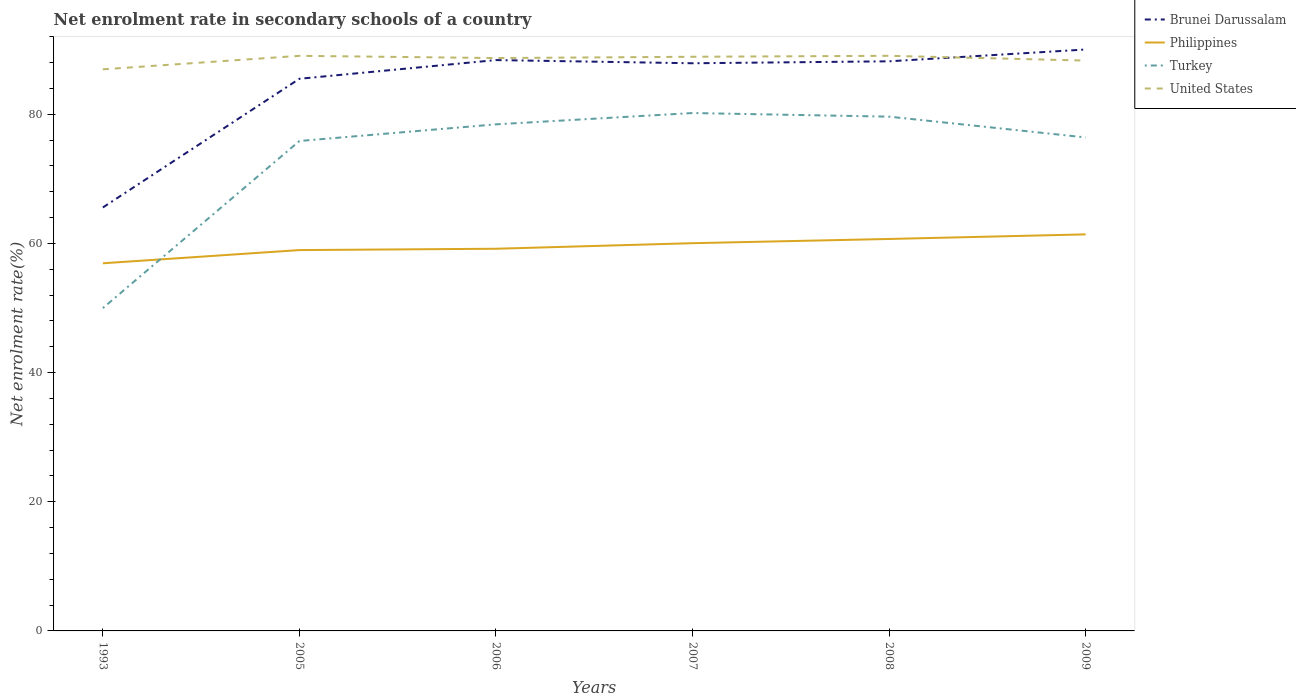How many different coloured lines are there?
Offer a very short reply. 4. Does the line corresponding to Philippines intersect with the line corresponding to Turkey?
Your answer should be compact. Yes. Across all years, what is the maximum net enrolment rate in secondary schools in United States?
Your answer should be compact. 86.95. What is the total net enrolment rate in secondary schools in Brunei Darussalam in the graph?
Give a very brief answer. -22.33. What is the difference between the highest and the second highest net enrolment rate in secondary schools in Brunei Darussalam?
Ensure brevity in your answer.  24.46. Is the net enrolment rate in secondary schools in Brunei Darussalam strictly greater than the net enrolment rate in secondary schools in Philippines over the years?
Your answer should be very brief. No. What is the difference between two consecutive major ticks on the Y-axis?
Give a very brief answer. 20. Does the graph contain grids?
Your response must be concise. No. Where does the legend appear in the graph?
Ensure brevity in your answer.  Top right. How many legend labels are there?
Ensure brevity in your answer.  4. How are the legend labels stacked?
Make the answer very short. Vertical. What is the title of the graph?
Provide a short and direct response. Net enrolment rate in secondary schools of a country. What is the label or title of the X-axis?
Provide a short and direct response. Years. What is the label or title of the Y-axis?
Make the answer very short. Net enrolment rate(%). What is the Net enrolment rate(%) of Brunei Darussalam in 1993?
Ensure brevity in your answer.  65.56. What is the Net enrolment rate(%) in Philippines in 1993?
Give a very brief answer. 56.92. What is the Net enrolment rate(%) of Turkey in 1993?
Your answer should be very brief. 49.98. What is the Net enrolment rate(%) of United States in 1993?
Provide a succinct answer. 86.95. What is the Net enrolment rate(%) in Brunei Darussalam in 2005?
Provide a short and direct response. 85.49. What is the Net enrolment rate(%) of Philippines in 2005?
Make the answer very short. 58.96. What is the Net enrolment rate(%) of Turkey in 2005?
Offer a terse response. 75.85. What is the Net enrolment rate(%) of United States in 2005?
Provide a succinct answer. 89.04. What is the Net enrolment rate(%) in Brunei Darussalam in 2006?
Make the answer very short. 88.38. What is the Net enrolment rate(%) in Philippines in 2006?
Make the answer very short. 59.17. What is the Net enrolment rate(%) in Turkey in 2006?
Give a very brief answer. 78.43. What is the Net enrolment rate(%) of United States in 2006?
Provide a succinct answer. 88.7. What is the Net enrolment rate(%) of Brunei Darussalam in 2007?
Keep it short and to the point. 87.89. What is the Net enrolment rate(%) in Philippines in 2007?
Offer a very short reply. 60.03. What is the Net enrolment rate(%) of Turkey in 2007?
Offer a terse response. 80.18. What is the Net enrolment rate(%) in United States in 2007?
Ensure brevity in your answer.  88.89. What is the Net enrolment rate(%) of Brunei Darussalam in 2008?
Provide a succinct answer. 88.19. What is the Net enrolment rate(%) of Philippines in 2008?
Give a very brief answer. 60.69. What is the Net enrolment rate(%) in Turkey in 2008?
Your answer should be compact. 79.62. What is the Net enrolment rate(%) of United States in 2008?
Your answer should be very brief. 89.04. What is the Net enrolment rate(%) in Brunei Darussalam in 2009?
Your answer should be very brief. 90.02. What is the Net enrolment rate(%) in Philippines in 2009?
Your answer should be very brief. 61.4. What is the Net enrolment rate(%) of Turkey in 2009?
Ensure brevity in your answer.  76.41. What is the Net enrolment rate(%) in United States in 2009?
Your answer should be very brief. 88.31. Across all years, what is the maximum Net enrolment rate(%) of Brunei Darussalam?
Offer a very short reply. 90.02. Across all years, what is the maximum Net enrolment rate(%) of Philippines?
Offer a very short reply. 61.4. Across all years, what is the maximum Net enrolment rate(%) in Turkey?
Your answer should be compact. 80.18. Across all years, what is the maximum Net enrolment rate(%) of United States?
Provide a short and direct response. 89.04. Across all years, what is the minimum Net enrolment rate(%) of Brunei Darussalam?
Ensure brevity in your answer.  65.56. Across all years, what is the minimum Net enrolment rate(%) of Philippines?
Keep it short and to the point. 56.92. Across all years, what is the minimum Net enrolment rate(%) of Turkey?
Your answer should be very brief. 49.98. Across all years, what is the minimum Net enrolment rate(%) in United States?
Offer a very short reply. 86.95. What is the total Net enrolment rate(%) of Brunei Darussalam in the graph?
Provide a short and direct response. 505.54. What is the total Net enrolment rate(%) of Philippines in the graph?
Your answer should be compact. 357.17. What is the total Net enrolment rate(%) in Turkey in the graph?
Keep it short and to the point. 440.48. What is the total Net enrolment rate(%) of United States in the graph?
Your answer should be very brief. 530.93. What is the difference between the Net enrolment rate(%) of Brunei Darussalam in 1993 and that in 2005?
Your answer should be compact. -19.93. What is the difference between the Net enrolment rate(%) in Philippines in 1993 and that in 2005?
Your answer should be compact. -2.04. What is the difference between the Net enrolment rate(%) of Turkey in 1993 and that in 2005?
Provide a succinct answer. -25.87. What is the difference between the Net enrolment rate(%) in United States in 1993 and that in 2005?
Your answer should be compact. -2.09. What is the difference between the Net enrolment rate(%) of Brunei Darussalam in 1993 and that in 2006?
Your answer should be very brief. -22.82. What is the difference between the Net enrolment rate(%) of Philippines in 1993 and that in 2006?
Your answer should be compact. -2.25. What is the difference between the Net enrolment rate(%) in Turkey in 1993 and that in 2006?
Make the answer very short. -28.45. What is the difference between the Net enrolment rate(%) of United States in 1993 and that in 2006?
Give a very brief answer. -1.74. What is the difference between the Net enrolment rate(%) of Brunei Darussalam in 1993 and that in 2007?
Ensure brevity in your answer.  -22.33. What is the difference between the Net enrolment rate(%) in Philippines in 1993 and that in 2007?
Give a very brief answer. -3.11. What is the difference between the Net enrolment rate(%) of Turkey in 1993 and that in 2007?
Keep it short and to the point. -30.2. What is the difference between the Net enrolment rate(%) in United States in 1993 and that in 2007?
Keep it short and to the point. -1.94. What is the difference between the Net enrolment rate(%) of Brunei Darussalam in 1993 and that in 2008?
Your response must be concise. -22.63. What is the difference between the Net enrolment rate(%) in Philippines in 1993 and that in 2008?
Your answer should be compact. -3.76. What is the difference between the Net enrolment rate(%) in Turkey in 1993 and that in 2008?
Your answer should be very brief. -29.64. What is the difference between the Net enrolment rate(%) of United States in 1993 and that in 2008?
Provide a short and direct response. -2.09. What is the difference between the Net enrolment rate(%) in Brunei Darussalam in 1993 and that in 2009?
Your answer should be compact. -24.46. What is the difference between the Net enrolment rate(%) of Philippines in 1993 and that in 2009?
Provide a succinct answer. -4.47. What is the difference between the Net enrolment rate(%) of Turkey in 1993 and that in 2009?
Make the answer very short. -26.42. What is the difference between the Net enrolment rate(%) in United States in 1993 and that in 2009?
Your answer should be very brief. -1.35. What is the difference between the Net enrolment rate(%) in Brunei Darussalam in 2005 and that in 2006?
Provide a short and direct response. -2.9. What is the difference between the Net enrolment rate(%) of Philippines in 2005 and that in 2006?
Provide a short and direct response. -0.21. What is the difference between the Net enrolment rate(%) of Turkey in 2005 and that in 2006?
Ensure brevity in your answer.  -2.58. What is the difference between the Net enrolment rate(%) in United States in 2005 and that in 2006?
Offer a terse response. 0.34. What is the difference between the Net enrolment rate(%) of Brunei Darussalam in 2005 and that in 2007?
Provide a short and direct response. -2.4. What is the difference between the Net enrolment rate(%) in Philippines in 2005 and that in 2007?
Your response must be concise. -1.07. What is the difference between the Net enrolment rate(%) in Turkey in 2005 and that in 2007?
Make the answer very short. -4.33. What is the difference between the Net enrolment rate(%) in United States in 2005 and that in 2007?
Your response must be concise. 0.15. What is the difference between the Net enrolment rate(%) of Brunei Darussalam in 2005 and that in 2008?
Your response must be concise. -2.7. What is the difference between the Net enrolment rate(%) in Philippines in 2005 and that in 2008?
Keep it short and to the point. -1.72. What is the difference between the Net enrolment rate(%) of Turkey in 2005 and that in 2008?
Your answer should be very brief. -3.77. What is the difference between the Net enrolment rate(%) of United States in 2005 and that in 2008?
Your answer should be very brief. -0. What is the difference between the Net enrolment rate(%) of Brunei Darussalam in 2005 and that in 2009?
Keep it short and to the point. -4.53. What is the difference between the Net enrolment rate(%) of Philippines in 2005 and that in 2009?
Your answer should be compact. -2.43. What is the difference between the Net enrolment rate(%) of Turkey in 2005 and that in 2009?
Provide a succinct answer. -0.55. What is the difference between the Net enrolment rate(%) in United States in 2005 and that in 2009?
Your response must be concise. 0.73. What is the difference between the Net enrolment rate(%) of Brunei Darussalam in 2006 and that in 2007?
Offer a terse response. 0.49. What is the difference between the Net enrolment rate(%) of Philippines in 2006 and that in 2007?
Your answer should be very brief. -0.86. What is the difference between the Net enrolment rate(%) in Turkey in 2006 and that in 2007?
Your response must be concise. -1.75. What is the difference between the Net enrolment rate(%) of United States in 2006 and that in 2007?
Your answer should be very brief. -0.2. What is the difference between the Net enrolment rate(%) of Brunei Darussalam in 2006 and that in 2008?
Keep it short and to the point. 0.19. What is the difference between the Net enrolment rate(%) in Philippines in 2006 and that in 2008?
Keep it short and to the point. -1.51. What is the difference between the Net enrolment rate(%) in Turkey in 2006 and that in 2008?
Offer a very short reply. -1.19. What is the difference between the Net enrolment rate(%) in United States in 2006 and that in 2008?
Provide a short and direct response. -0.35. What is the difference between the Net enrolment rate(%) in Brunei Darussalam in 2006 and that in 2009?
Keep it short and to the point. -1.64. What is the difference between the Net enrolment rate(%) in Philippines in 2006 and that in 2009?
Make the answer very short. -2.22. What is the difference between the Net enrolment rate(%) in Turkey in 2006 and that in 2009?
Ensure brevity in your answer.  2.03. What is the difference between the Net enrolment rate(%) in United States in 2006 and that in 2009?
Ensure brevity in your answer.  0.39. What is the difference between the Net enrolment rate(%) of Brunei Darussalam in 2007 and that in 2008?
Provide a succinct answer. -0.3. What is the difference between the Net enrolment rate(%) of Philippines in 2007 and that in 2008?
Ensure brevity in your answer.  -0.65. What is the difference between the Net enrolment rate(%) of Turkey in 2007 and that in 2008?
Your answer should be compact. 0.56. What is the difference between the Net enrolment rate(%) of United States in 2007 and that in 2008?
Keep it short and to the point. -0.15. What is the difference between the Net enrolment rate(%) in Brunei Darussalam in 2007 and that in 2009?
Make the answer very short. -2.13. What is the difference between the Net enrolment rate(%) in Philippines in 2007 and that in 2009?
Offer a terse response. -1.36. What is the difference between the Net enrolment rate(%) in Turkey in 2007 and that in 2009?
Provide a succinct answer. 3.78. What is the difference between the Net enrolment rate(%) of United States in 2007 and that in 2009?
Your answer should be very brief. 0.59. What is the difference between the Net enrolment rate(%) in Brunei Darussalam in 2008 and that in 2009?
Provide a short and direct response. -1.83. What is the difference between the Net enrolment rate(%) of Philippines in 2008 and that in 2009?
Ensure brevity in your answer.  -0.71. What is the difference between the Net enrolment rate(%) of Turkey in 2008 and that in 2009?
Ensure brevity in your answer.  3.22. What is the difference between the Net enrolment rate(%) of United States in 2008 and that in 2009?
Your answer should be compact. 0.74. What is the difference between the Net enrolment rate(%) of Brunei Darussalam in 1993 and the Net enrolment rate(%) of Philippines in 2005?
Ensure brevity in your answer.  6.6. What is the difference between the Net enrolment rate(%) of Brunei Darussalam in 1993 and the Net enrolment rate(%) of Turkey in 2005?
Your answer should be compact. -10.29. What is the difference between the Net enrolment rate(%) in Brunei Darussalam in 1993 and the Net enrolment rate(%) in United States in 2005?
Give a very brief answer. -23.48. What is the difference between the Net enrolment rate(%) of Philippines in 1993 and the Net enrolment rate(%) of Turkey in 2005?
Offer a very short reply. -18.93. What is the difference between the Net enrolment rate(%) of Philippines in 1993 and the Net enrolment rate(%) of United States in 2005?
Your response must be concise. -32.12. What is the difference between the Net enrolment rate(%) in Turkey in 1993 and the Net enrolment rate(%) in United States in 2005?
Make the answer very short. -39.06. What is the difference between the Net enrolment rate(%) in Brunei Darussalam in 1993 and the Net enrolment rate(%) in Philippines in 2006?
Ensure brevity in your answer.  6.39. What is the difference between the Net enrolment rate(%) of Brunei Darussalam in 1993 and the Net enrolment rate(%) of Turkey in 2006?
Make the answer very short. -12.87. What is the difference between the Net enrolment rate(%) of Brunei Darussalam in 1993 and the Net enrolment rate(%) of United States in 2006?
Your answer should be very brief. -23.13. What is the difference between the Net enrolment rate(%) in Philippines in 1993 and the Net enrolment rate(%) in Turkey in 2006?
Offer a very short reply. -21.51. What is the difference between the Net enrolment rate(%) of Philippines in 1993 and the Net enrolment rate(%) of United States in 2006?
Your answer should be compact. -31.77. What is the difference between the Net enrolment rate(%) in Turkey in 1993 and the Net enrolment rate(%) in United States in 2006?
Make the answer very short. -38.71. What is the difference between the Net enrolment rate(%) of Brunei Darussalam in 1993 and the Net enrolment rate(%) of Philippines in 2007?
Provide a short and direct response. 5.53. What is the difference between the Net enrolment rate(%) in Brunei Darussalam in 1993 and the Net enrolment rate(%) in Turkey in 2007?
Ensure brevity in your answer.  -14.62. What is the difference between the Net enrolment rate(%) of Brunei Darussalam in 1993 and the Net enrolment rate(%) of United States in 2007?
Offer a very short reply. -23.33. What is the difference between the Net enrolment rate(%) in Philippines in 1993 and the Net enrolment rate(%) in Turkey in 2007?
Your response must be concise. -23.26. What is the difference between the Net enrolment rate(%) of Philippines in 1993 and the Net enrolment rate(%) of United States in 2007?
Make the answer very short. -31.97. What is the difference between the Net enrolment rate(%) in Turkey in 1993 and the Net enrolment rate(%) in United States in 2007?
Your response must be concise. -38.91. What is the difference between the Net enrolment rate(%) of Brunei Darussalam in 1993 and the Net enrolment rate(%) of Philippines in 2008?
Offer a terse response. 4.88. What is the difference between the Net enrolment rate(%) in Brunei Darussalam in 1993 and the Net enrolment rate(%) in Turkey in 2008?
Keep it short and to the point. -14.06. What is the difference between the Net enrolment rate(%) of Brunei Darussalam in 1993 and the Net enrolment rate(%) of United States in 2008?
Your answer should be very brief. -23.48. What is the difference between the Net enrolment rate(%) of Philippines in 1993 and the Net enrolment rate(%) of Turkey in 2008?
Make the answer very short. -22.7. What is the difference between the Net enrolment rate(%) of Philippines in 1993 and the Net enrolment rate(%) of United States in 2008?
Provide a succinct answer. -32.12. What is the difference between the Net enrolment rate(%) of Turkey in 1993 and the Net enrolment rate(%) of United States in 2008?
Your response must be concise. -39.06. What is the difference between the Net enrolment rate(%) in Brunei Darussalam in 1993 and the Net enrolment rate(%) in Philippines in 2009?
Your answer should be compact. 4.17. What is the difference between the Net enrolment rate(%) of Brunei Darussalam in 1993 and the Net enrolment rate(%) of Turkey in 2009?
Your response must be concise. -10.84. What is the difference between the Net enrolment rate(%) in Brunei Darussalam in 1993 and the Net enrolment rate(%) in United States in 2009?
Make the answer very short. -22.74. What is the difference between the Net enrolment rate(%) of Philippines in 1993 and the Net enrolment rate(%) of Turkey in 2009?
Give a very brief answer. -19.48. What is the difference between the Net enrolment rate(%) of Philippines in 1993 and the Net enrolment rate(%) of United States in 2009?
Ensure brevity in your answer.  -31.39. What is the difference between the Net enrolment rate(%) in Turkey in 1993 and the Net enrolment rate(%) in United States in 2009?
Keep it short and to the point. -38.32. What is the difference between the Net enrolment rate(%) in Brunei Darussalam in 2005 and the Net enrolment rate(%) in Philippines in 2006?
Give a very brief answer. 26.32. What is the difference between the Net enrolment rate(%) of Brunei Darussalam in 2005 and the Net enrolment rate(%) of Turkey in 2006?
Ensure brevity in your answer.  7.06. What is the difference between the Net enrolment rate(%) in Brunei Darussalam in 2005 and the Net enrolment rate(%) in United States in 2006?
Give a very brief answer. -3.21. What is the difference between the Net enrolment rate(%) of Philippines in 2005 and the Net enrolment rate(%) of Turkey in 2006?
Keep it short and to the point. -19.47. What is the difference between the Net enrolment rate(%) of Philippines in 2005 and the Net enrolment rate(%) of United States in 2006?
Your answer should be very brief. -29.73. What is the difference between the Net enrolment rate(%) in Turkey in 2005 and the Net enrolment rate(%) in United States in 2006?
Offer a very short reply. -12.84. What is the difference between the Net enrolment rate(%) of Brunei Darussalam in 2005 and the Net enrolment rate(%) of Philippines in 2007?
Your response must be concise. 25.46. What is the difference between the Net enrolment rate(%) of Brunei Darussalam in 2005 and the Net enrolment rate(%) of Turkey in 2007?
Offer a very short reply. 5.3. What is the difference between the Net enrolment rate(%) in Brunei Darussalam in 2005 and the Net enrolment rate(%) in United States in 2007?
Offer a terse response. -3.41. What is the difference between the Net enrolment rate(%) in Philippines in 2005 and the Net enrolment rate(%) in Turkey in 2007?
Your answer should be very brief. -21.22. What is the difference between the Net enrolment rate(%) in Philippines in 2005 and the Net enrolment rate(%) in United States in 2007?
Provide a succinct answer. -29.93. What is the difference between the Net enrolment rate(%) of Turkey in 2005 and the Net enrolment rate(%) of United States in 2007?
Make the answer very short. -13.04. What is the difference between the Net enrolment rate(%) in Brunei Darussalam in 2005 and the Net enrolment rate(%) in Philippines in 2008?
Provide a succinct answer. 24.8. What is the difference between the Net enrolment rate(%) of Brunei Darussalam in 2005 and the Net enrolment rate(%) of Turkey in 2008?
Keep it short and to the point. 5.86. What is the difference between the Net enrolment rate(%) of Brunei Darussalam in 2005 and the Net enrolment rate(%) of United States in 2008?
Ensure brevity in your answer.  -3.56. What is the difference between the Net enrolment rate(%) in Philippines in 2005 and the Net enrolment rate(%) in Turkey in 2008?
Ensure brevity in your answer.  -20.66. What is the difference between the Net enrolment rate(%) in Philippines in 2005 and the Net enrolment rate(%) in United States in 2008?
Keep it short and to the point. -30.08. What is the difference between the Net enrolment rate(%) of Turkey in 2005 and the Net enrolment rate(%) of United States in 2008?
Provide a short and direct response. -13.19. What is the difference between the Net enrolment rate(%) of Brunei Darussalam in 2005 and the Net enrolment rate(%) of Philippines in 2009?
Make the answer very short. 24.09. What is the difference between the Net enrolment rate(%) in Brunei Darussalam in 2005 and the Net enrolment rate(%) in Turkey in 2009?
Your response must be concise. 9.08. What is the difference between the Net enrolment rate(%) of Brunei Darussalam in 2005 and the Net enrolment rate(%) of United States in 2009?
Offer a very short reply. -2.82. What is the difference between the Net enrolment rate(%) in Philippines in 2005 and the Net enrolment rate(%) in Turkey in 2009?
Keep it short and to the point. -17.44. What is the difference between the Net enrolment rate(%) of Philippines in 2005 and the Net enrolment rate(%) of United States in 2009?
Provide a short and direct response. -29.34. What is the difference between the Net enrolment rate(%) in Turkey in 2005 and the Net enrolment rate(%) in United States in 2009?
Offer a terse response. -12.45. What is the difference between the Net enrolment rate(%) in Brunei Darussalam in 2006 and the Net enrolment rate(%) in Philippines in 2007?
Keep it short and to the point. 28.35. What is the difference between the Net enrolment rate(%) of Brunei Darussalam in 2006 and the Net enrolment rate(%) of Turkey in 2007?
Keep it short and to the point. 8.2. What is the difference between the Net enrolment rate(%) in Brunei Darussalam in 2006 and the Net enrolment rate(%) in United States in 2007?
Give a very brief answer. -0.51. What is the difference between the Net enrolment rate(%) of Philippines in 2006 and the Net enrolment rate(%) of Turkey in 2007?
Make the answer very short. -21.01. What is the difference between the Net enrolment rate(%) of Philippines in 2006 and the Net enrolment rate(%) of United States in 2007?
Give a very brief answer. -29.72. What is the difference between the Net enrolment rate(%) of Turkey in 2006 and the Net enrolment rate(%) of United States in 2007?
Keep it short and to the point. -10.46. What is the difference between the Net enrolment rate(%) of Brunei Darussalam in 2006 and the Net enrolment rate(%) of Philippines in 2008?
Offer a very short reply. 27.7. What is the difference between the Net enrolment rate(%) of Brunei Darussalam in 2006 and the Net enrolment rate(%) of Turkey in 2008?
Keep it short and to the point. 8.76. What is the difference between the Net enrolment rate(%) in Brunei Darussalam in 2006 and the Net enrolment rate(%) in United States in 2008?
Provide a short and direct response. -0.66. What is the difference between the Net enrolment rate(%) in Philippines in 2006 and the Net enrolment rate(%) in Turkey in 2008?
Provide a succinct answer. -20.45. What is the difference between the Net enrolment rate(%) in Philippines in 2006 and the Net enrolment rate(%) in United States in 2008?
Offer a very short reply. -29.87. What is the difference between the Net enrolment rate(%) of Turkey in 2006 and the Net enrolment rate(%) of United States in 2008?
Make the answer very short. -10.61. What is the difference between the Net enrolment rate(%) in Brunei Darussalam in 2006 and the Net enrolment rate(%) in Philippines in 2009?
Ensure brevity in your answer.  26.99. What is the difference between the Net enrolment rate(%) of Brunei Darussalam in 2006 and the Net enrolment rate(%) of Turkey in 2009?
Provide a succinct answer. 11.98. What is the difference between the Net enrolment rate(%) of Brunei Darussalam in 2006 and the Net enrolment rate(%) of United States in 2009?
Ensure brevity in your answer.  0.08. What is the difference between the Net enrolment rate(%) of Philippines in 2006 and the Net enrolment rate(%) of Turkey in 2009?
Provide a short and direct response. -17.23. What is the difference between the Net enrolment rate(%) in Philippines in 2006 and the Net enrolment rate(%) in United States in 2009?
Offer a very short reply. -29.14. What is the difference between the Net enrolment rate(%) of Turkey in 2006 and the Net enrolment rate(%) of United States in 2009?
Your response must be concise. -9.87. What is the difference between the Net enrolment rate(%) of Brunei Darussalam in 2007 and the Net enrolment rate(%) of Philippines in 2008?
Your answer should be very brief. 27.2. What is the difference between the Net enrolment rate(%) in Brunei Darussalam in 2007 and the Net enrolment rate(%) in Turkey in 2008?
Keep it short and to the point. 8.27. What is the difference between the Net enrolment rate(%) of Brunei Darussalam in 2007 and the Net enrolment rate(%) of United States in 2008?
Ensure brevity in your answer.  -1.15. What is the difference between the Net enrolment rate(%) in Philippines in 2007 and the Net enrolment rate(%) in Turkey in 2008?
Keep it short and to the point. -19.59. What is the difference between the Net enrolment rate(%) of Philippines in 2007 and the Net enrolment rate(%) of United States in 2008?
Ensure brevity in your answer.  -29.01. What is the difference between the Net enrolment rate(%) of Turkey in 2007 and the Net enrolment rate(%) of United States in 2008?
Provide a succinct answer. -8.86. What is the difference between the Net enrolment rate(%) in Brunei Darussalam in 2007 and the Net enrolment rate(%) in Philippines in 2009?
Offer a terse response. 26.49. What is the difference between the Net enrolment rate(%) in Brunei Darussalam in 2007 and the Net enrolment rate(%) in Turkey in 2009?
Your answer should be compact. 11.48. What is the difference between the Net enrolment rate(%) of Brunei Darussalam in 2007 and the Net enrolment rate(%) of United States in 2009?
Offer a very short reply. -0.42. What is the difference between the Net enrolment rate(%) of Philippines in 2007 and the Net enrolment rate(%) of Turkey in 2009?
Make the answer very short. -16.37. What is the difference between the Net enrolment rate(%) in Philippines in 2007 and the Net enrolment rate(%) in United States in 2009?
Provide a short and direct response. -28.27. What is the difference between the Net enrolment rate(%) of Turkey in 2007 and the Net enrolment rate(%) of United States in 2009?
Your answer should be very brief. -8.12. What is the difference between the Net enrolment rate(%) of Brunei Darussalam in 2008 and the Net enrolment rate(%) of Philippines in 2009?
Your answer should be compact. 26.8. What is the difference between the Net enrolment rate(%) of Brunei Darussalam in 2008 and the Net enrolment rate(%) of Turkey in 2009?
Your response must be concise. 11.79. What is the difference between the Net enrolment rate(%) of Brunei Darussalam in 2008 and the Net enrolment rate(%) of United States in 2009?
Provide a short and direct response. -0.11. What is the difference between the Net enrolment rate(%) of Philippines in 2008 and the Net enrolment rate(%) of Turkey in 2009?
Your response must be concise. -15.72. What is the difference between the Net enrolment rate(%) in Philippines in 2008 and the Net enrolment rate(%) in United States in 2009?
Give a very brief answer. -27.62. What is the difference between the Net enrolment rate(%) of Turkey in 2008 and the Net enrolment rate(%) of United States in 2009?
Provide a succinct answer. -8.68. What is the average Net enrolment rate(%) in Brunei Darussalam per year?
Your answer should be very brief. 84.26. What is the average Net enrolment rate(%) of Philippines per year?
Keep it short and to the point. 59.53. What is the average Net enrolment rate(%) of Turkey per year?
Keep it short and to the point. 73.41. What is the average Net enrolment rate(%) in United States per year?
Your response must be concise. 88.49. In the year 1993, what is the difference between the Net enrolment rate(%) of Brunei Darussalam and Net enrolment rate(%) of Philippines?
Make the answer very short. 8.64. In the year 1993, what is the difference between the Net enrolment rate(%) of Brunei Darussalam and Net enrolment rate(%) of Turkey?
Provide a succinct answer. 15.58. In the year 1993, what is the difference between the Net enrolment rate(%) in Brunei Darussalam and Net enrolment rate(%) in United States?
Provide a short and direct response. -21.39. In the year 1993, what is the difference between the Net enrolment rate(%) in Philippines and Net enrolment rate(%) in Turkey?
Give a very brief answer. 6.94. In the year 1993, what is the difference between the Net enrolment rate(%) in Philippines and Net enrolment rate(%) in United States?
Offer a terse response. -30.03. In the year 1993, what is the difference between the Net enrolment rate(%) of Turkey and Net enrolment rate(%) of United States?
Make the answer very short. -36.97. In the year 2005, what is the difference between the Net enrolment rate(%) of Brunei Darussalam and Net enrolment rate(%) of Philippines?
Make the answer very short. 26.52. In the year 2005, what is the difference between the Net enrolment rate(%) of Brunei Darussalam and Net enrolment rate(%) of Turkey?
Make the answer very short. 9.63. In the year 2005, what is the difference between the Net enrolment rate(%) of Brunei Darussalam and Net enrolment rate(%) of United States?
Keep it short and to the point. -3.55. In the year 2005, what is the difference between the Net enrolment rate(%) in Philippines and Net enrolment rate(%) in Turkey?
Ensure brevity in your answer.  -16.89. In the year 2005, what is the difference between the Net enrolment rate(%) in Philippines and Net enrolment rate(%) in United States?
Your answer should be very brief. -30.08. In the year 2005, what is the difference between the Net enrolment rate(%) of Turkey and Net enrolment rate(%) of United States?
Provide a succinct answer. -13.19. In the year 2006, what is the difference between the Net enrolment rate(%) of Brunei Darussalam and Net enrolment rate(%) of Philippines?
Offer a terse response. 29.21. In the year 2006, what is the difference between the Net enrolment rate(%) in Brunei Darussalam and Net enrolment rate(%) in Turkey?
Keep it short and to the point. 9.95. In the year 2006, what is the difference between the Net enrolment rate(%) in Brunei Darussalam and Net enrolment rate(%) in United States?
Offer a terse response. -0.31. In the year 2006, what is the difference between the Net enrolment rate(%) in Philippines and Net enrolment rate(%) in Turkey?
Keep it short and to the point. -19.26. In the year 2006, what is the difference between the Net enrolment rate(%) of Philippines and Net enrolment rate(%) of United States?
Give a very brief answer. -29.53. In the year 2006, what is the difference between the Net enrolment rate(%) in Turkey and Net enrolment rate(%) in United States?
Provide a succinct answer. -10.26. In the year 2007, what is the difference between the Net enrolment rate(%) of Brunei Darussalam and Net enrolment rate(%) of Philippines?
Make the answer very short. 27.86. In the year 2007, what is the difference between the Net enrolment rate(%) of Brunei Darussalam and Net enrolment rate(%) of Turkey?
Make the answer very short. 7.71. In the year 2007, what is the difference between the Net enrolment rate(%) of Brunei Darussalam and Net enrolment rate(%) of United States?
Provide a short and direct response. -1. In the year 2007, what is the difference between the Net enrolment rate(%) of Philippines and Net enrolment rate(%) of Turkey?
Offer a terse response. -20.15. In the year 2007, what is the difference between the Net enrolment rate(%) in Philippines and Net enrolment rate(%) in United States?
Your answer should be compact. -28.86. In the year 2007, what is the difference between the Net enrolment rate(%) of Turkey and Net enrolment rate(%) of United States?
Ensure brevity in your answer.  -8.71. In the year 2008, what is the difference between the Net enrolment rate(%) of Brunei Darussalam and Net enrolment rate(%) of Philippines?
Offer a very short reply. 27.51. In the year 2008, what is the difference between the Net enrolment rate(%) in Brunei Darussalam and Net enrolment rate(%) in Turkey?
Your answer should be compact. 8.57. In the year 2008, what is the difference between the Net enrolment rate(%) of Brunei Darussalam and Net enrolment rate(%) of United States?
Keep it short and to the point. -0.85. In the year 2008, what is the difference between the Net enrolment rate(%) of Philippines and Net enrolment rate(%) of Turkey?
Offer a very short reply. -18.94. In the year 2008, what is the difference between the Net enrolment rate(%) of Philippines and Net enrolment rate(%) of United States?
Your answer should be very brief. -28.36. In the year 2008, what is the difference between the Net enrolment rate(%) of Turkey and Net enrolment rate(%) of United States?
Offer a very short reply. -9.42. In the year 2009, what is the difference between the Net enrolment rate(%) in Brunei Darussalam and Net enrolment rate(%) in Philippines?
Provide a short and direct response. 28.62. In the year 2009, what is the difference between the Net enrolment rate(%) of Brunei Darussalam and Net enrolment rate(%) of Turkey?
Give a very brief answer. 13.61. In the year 2009, what is the difference between the Net enrolment rate(%) of Brunei Darussalam and Net enrolment rate(%) of United States?
Provide a short and direct response. 1.71. In the year 2009, what is the difference between the Net enrolment rate(%) in Philippines and Net enrolment rate(%) in Turkey?
Provide a succinct answer. -15.01. In the year 2009, what is the difference between the Net enrolment rate(%) in Philippines and Net enrolment rate(%) in United States?
Make the answer very short. -26.91. In the year 2009, what is the difference between the Net enrolment rate(%) in Turkey and Net enrolment rate(%) in United States?
Ensure brevity in your answer.  -11.9. What is the ratio of the Net enrolment rate(%) in Brunei Darussalam in 1993 to that in 2005?
Your answer should be compact. 0.77. What is the ratio of the Net enrolment rate(%) in Philippines in 1993 to that in 2005?
Provide a succinct answer. 0.97. What is the ratio of the Net enrolment rate(%) of Turkey in 1993 to that in 2005?
Provide a succinct answer. 0.66. What is the ratio of the Net enrolment rate(%) in United States in 1993 to that in 2005?
Keep it short and to the point. 0.98. What is the ratio of the Net enrolment rate(%) of Brunei Darussalam in 1993 to that in 2006?
Provide a succinct answer. 0.74. What is the ratio of the Net enrolment rate(%) in Philippines in 1993 to that in 2006?
Provide a short and direct response. 0.96. What is the ratio of the Net enrolment rate(%) of Turkey in 1993 to that in 2006?
Ensure brevity in your answer.  0.64. What is the ratio of the Net enrolment rate(%) in United States in 1993 to that in 2006?
Offer a terse response. 0.98. What is the ratio of the Net enrolment rate(%) in Brunei Darussalam in 1993 to that in 2007?
Provide a short and direct response. 0.75. What is the ratio of the Net enrolment rate(%) of Philippines in 1993 to that in 2007?
Your answer should be very brief. 0.95. What is the ratio of the Net enrolment rate(%) in Turkey in 1993 to that in 2007?
Your response must be concise. 0.62. What is the ratio of the Net enrolment rate(%) in United States in 1993 to that in 2007?
Provide a short and direct response. 0.98. What is the ratio of the Net enrolment rate(%) of Brunei Darussalam in 1993 to that in 2008?
Your answer should be very brief. 0.74. What is the ratio of the Net enrolment rate(%) of Philippines in 1993 to that in 2008?
Ensure brevity in your answer.  0.94. What is the ratio of the Net enrolment rate(%) in Turkey in 1993 to that in 2008?
Your response must be concise. 0.63. What is the ratio of the Net enrolment rate(%) of United States in 1993 to that in 2008?
Ensure brevity in your answer.  0.98. What is the ratio of the Net enrolment rate(%) in Brunei Darussalam in 1993 to that in 2009?
Make the answer very short. 0.73. What is the ratio of the Net enrolment rate(%) in Philippines in 1993 to that in 2009?
Offer a terse response. 0.93. What is the ratio of the Net enrolment rate(%) of Turkey in 1993 to that in 2009?
Provide a short and direct response. 0.65. What is the ratio of the Net enrolment rate(%) of United States in 1993 to that in 2009?
Your answer should be compact. 0.98. What is the ratio of the Net enrolment rate(%) in Brunei Darussalam in 2005 to that in 2006?
Give a very brief answer. 0.97. What is the ratio of the Net enrolment rate(%) of Turkey in 2005 to that in 2006?
Keep it short and to the point. 0.97. What is the ratio of the Net enrolment rate(%) of United States in 2005 to that in 2006?
Offer a very short reply. 1. What is the ratio of the Net enrolment rate(%) in Brunei Darussalam in 2005 to that in 2007?
Give a very brief answer. 0.97. What is the ratio of the Net enrolment rate(%) in Philippines in 2005 to that in 2007?
Ensure brevity in your answer.  0.98. What is the ratio of the Net enrolment rate(%) of Turkey in 2005 to that in 2007?
Offer a very short reply. 0.95. What is the ratio of the Net enrolment rate(%) of Brunei Darussalam in 2005 to that in 2008?
Provide a succinct answer. 0.97. What is the ratio of the Net enrolment rate(%) of Philippines in 2005 to that in 2008?
Your response must be concise. 0.97. What is the ratio of the Net enrolment rate(%) of Turkey in 2005 to that in 2008?
Provide a succinct answer. 0.95. What is the ratio of the Net enrolment rate(%) in United States in 2005 to that in 2008?
Keep it short and to the point. 1. What is the ratio of the Net enrolment rate(%) in Brunei Darussalam in 2005 to that in 2009?
Make the answer very short. 0.95. What is the ratio of the Net enrolment rate(%) in Philippines in 2005 to that in 2009?
Ensure brevity in your answer.  0.96. What is the ratio of the Net enrolment rate(%) of United States in 2005 to that in 2009?
Your answer should be compact. 1.01. What is the ratio of the Net enrolment rate(%) in Brunei Darussalam in 2006 to that in 2007?
Offer a terse response. 1.01. What is the ratio of the Net enrolment rate(%) in Philippines in 2006 to that in 2007?
Provide a short and direct response. 0.99. What is the ratio of the Net enrolment rate(%) of Turkey in 2006 to that in 2007?
Provide a short and direct response. 0.98. What is the ratio of the Net enrolment rate(%) in Brunei Darussalam in 2006 to that in 2008?
Ensure brevity in your answer.  1. What is the ratio of the Net enrolment rate(%) in Philippines in 2006 to that in 2008?
Keep it short and to the point. 0.97. What is the ratio of the Net enrolment rate(%) in Turkey in 2006 to that in 2008?
Make the answer very short. 0.98. What is the ratio of the Net enrolment rate(%) in Brunei Darussalam in 2006 to that in 2009?
Offer a very short reply. 0.98. What is the ratio of the Net enrolment rate(%) in Philippines in 2006 to that in 2009?
Offer a very short reply. 0.96. What is the ratio of the Net enrolment rate(%) of Turkey in 2006 to that in 2009?
Offer a very short reply. 1.03. What is the ratio of the Net enrolment rate(%) in United States in 2006 to that in 2009?
Your response must be concise. 1. What is the ratio of the Net enrolment rate(%) of Philippines in 2007 to that in 2008?
Provide a short and direct response. 0.99. What is the ratio of the Net enrolment rate(%) in United States in 2007 to that in 2008?
Ensure brevity in your answer.  1. What is the ratio of the Net enrolment rate(%) of Brunei Darussalam in 2007 to that in 2009?
Offer a very short reply. 0.98. What is the ratio of the Net enrolment rate(%) of Philippines in 2007 to that in 2009?
Provide a succinct answer. 0.98. What is the ratio of the Net enrolment rate(%) in Turkey in 2007 to that in 2009?
Provide a succinct answer. 1.05. What is the ratio of the Net enrolment rate(%) of Brunei Darussalam in 2008 to that in 2009?
Your answer should be compact. 0.98. What is the ratio of the Net enrolment rate(%) of Philippines in 2008 to that in 2009?
Your response must be concise. 0.99. What is the ratio of the Net enrolment rate(%) of Turkey in 2008 to that in 2009?
Provide a short and direct response. 1.04. What is the ratio of the Net enrolment rate(%) in United States in 2008 to that in 2009?
Give a very brief answer. 1.01. What is the difference between the highest and the second highest Net enrolment rate(%) of Brunei Darussalam?
Keep it short and to the point. 1.64. What is the difference between the highest and the second highest Net enrolment rate(%) of Philippines?
Make the answer very short. 0.71. What is the difference between the highest and the second highest Net enrolment rate(%) of Turkey?
Ensure brevity in your answer.  0.56. What is the difference between the highest and the second highest Net enrolment rate(%) in United States?
Your response must be concise. 0. What is the difference between the highest and the lowest Net enrolment rate(%) in Brunei Darussalam?
Your answer should be compact. 24.46. What is the difference between the highest and the lowest Net enrolment rate(%) of Philippines?
Your answer should be very brief. 4.47. What is the difference between the highest and the lowest Net enrolment rate(%) in Turkey?
Your response must be concise. 30.2. What is the difference between the highest and the lowest Net enrolment rate(%) of United States?
Keep it short and to the point. 2.09. 